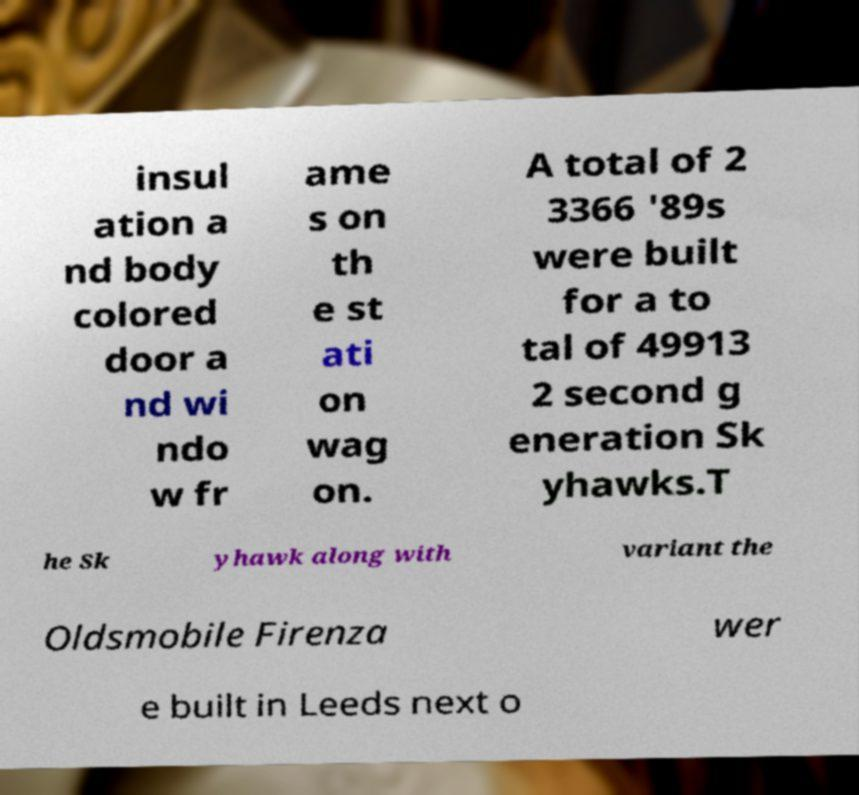I need the written content from this picture converted into text. Can you do that? insul ation a nd body colored door a nd wi ndo w fr ame s on th e st ati on wag on. A total of 2 3366 '89s were built for a to tal of 49913 2 second g eneration Sk yhawks.T he Sk yhawk along with variant the Oldsmobile Firenza wer e built in Leeds next o 